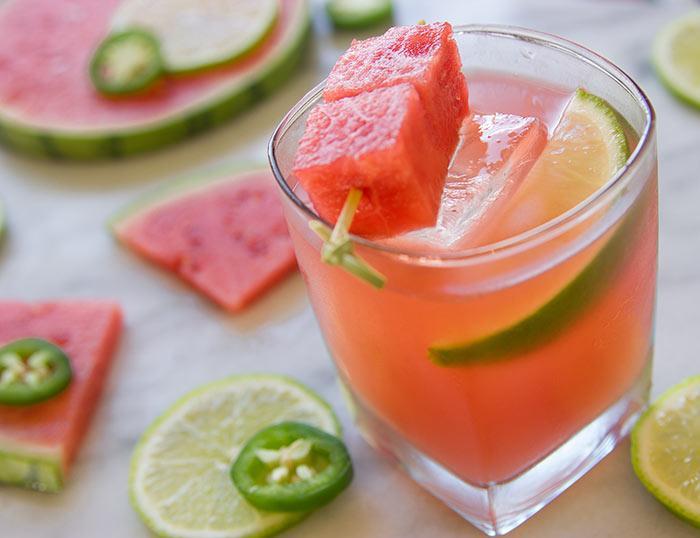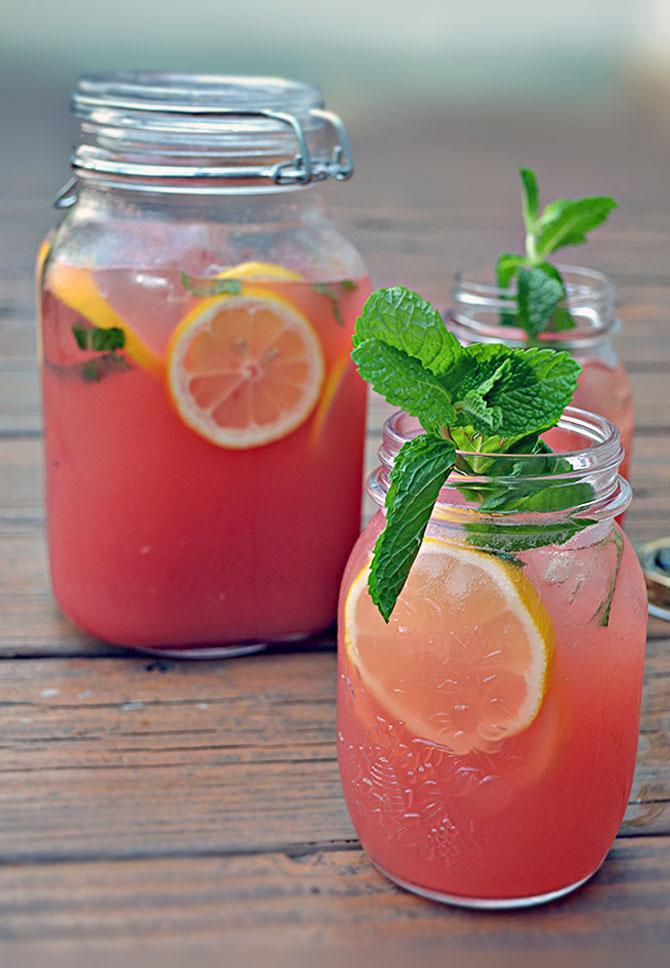The first image is the image on the left, the second image is the image on the right. Evaluate the accuracy of this statement regarding the images: "One image has a watermelon garnish on the glass.". Is it true? Answer yes or no. Yes. The first image is the image on the left, the second image is the image on the right. For the images displayed, is the sentence "One image shows drink ingredients only, including watermelon and lemon." factually correct? Answer yes or no. No. 